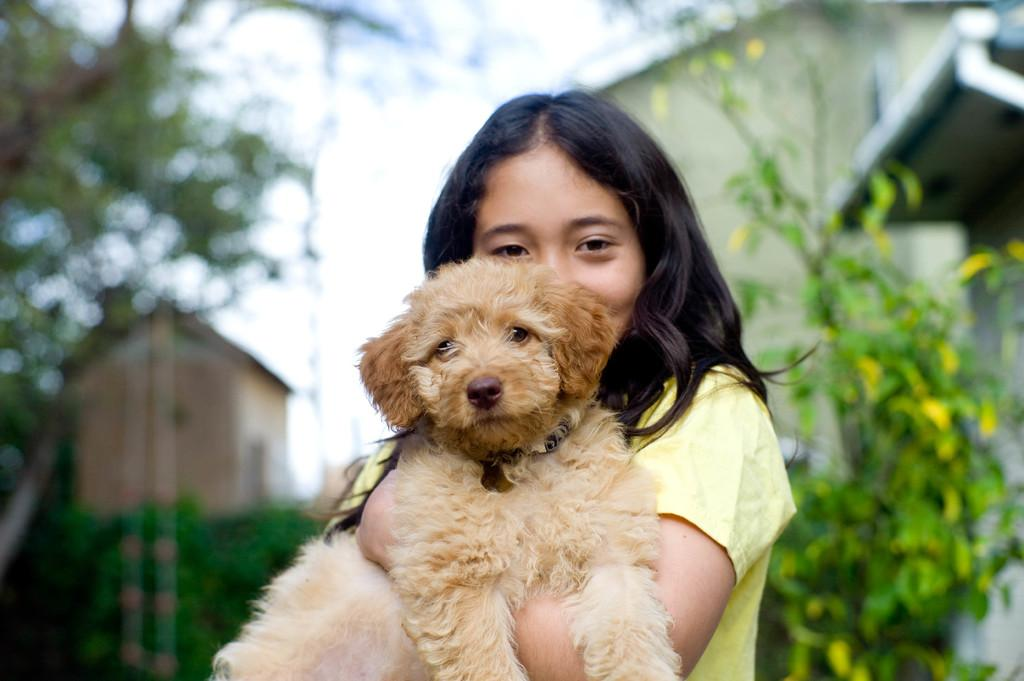Who is the main subject in the image? There is a girl in the image. What is the girl wearing? The girl is wearing a yellow dress. What is the girl holding in the image? The girl is holding a dog. What can be seen in the background of the image? There is a building, trees, and the sky visible in the background of the image. How many letters can be seen in the image? There are no letters visible in the image. 